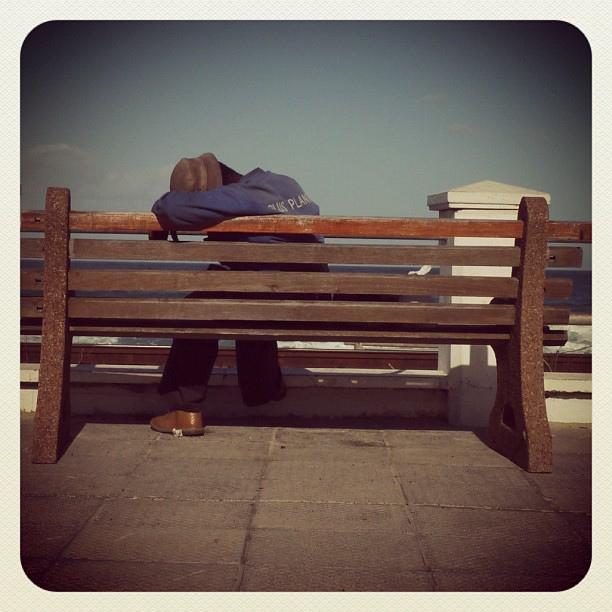What material is the bench made of?
Write a very short answer. Wood. What is this person doing on the bench?
Answer briefly. Sleeping. Is it raining in this scene?
Quick response, please. No. 